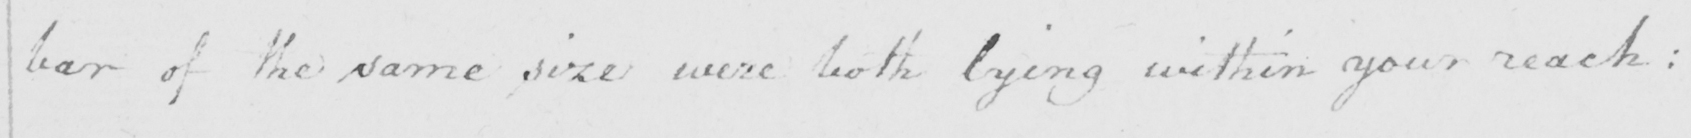What is written in this line of handwriting? bar of the same size were both lying within your reach: 